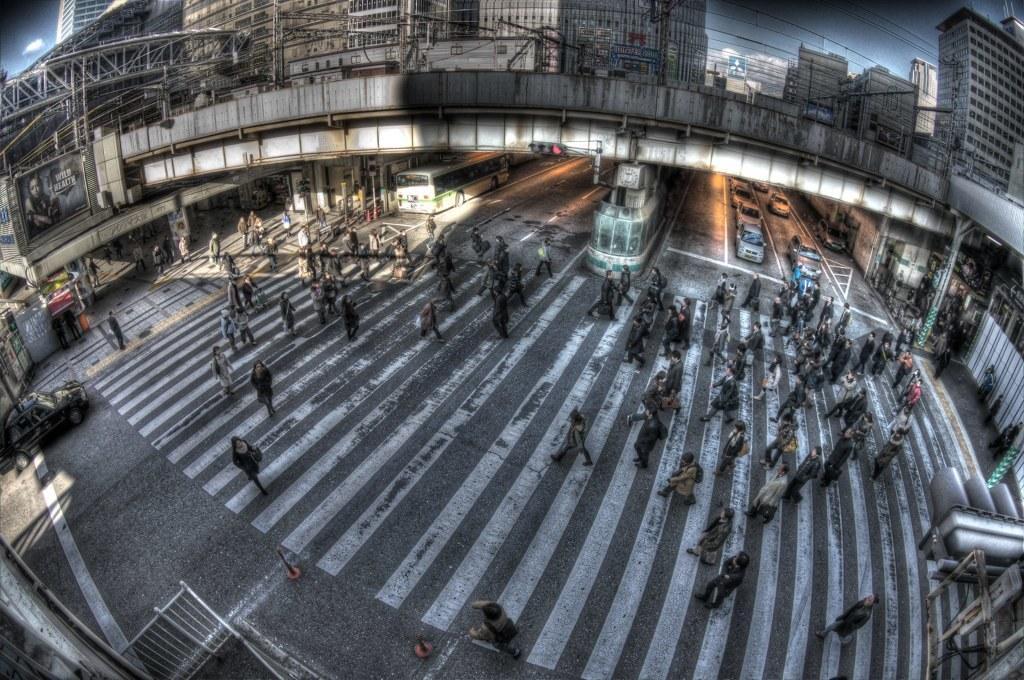How would you summarize this image in a sentence or two? In this image we can see some people and there are some vehicles on the road and there is a bridge over the road. We can see some buildings in the background. 